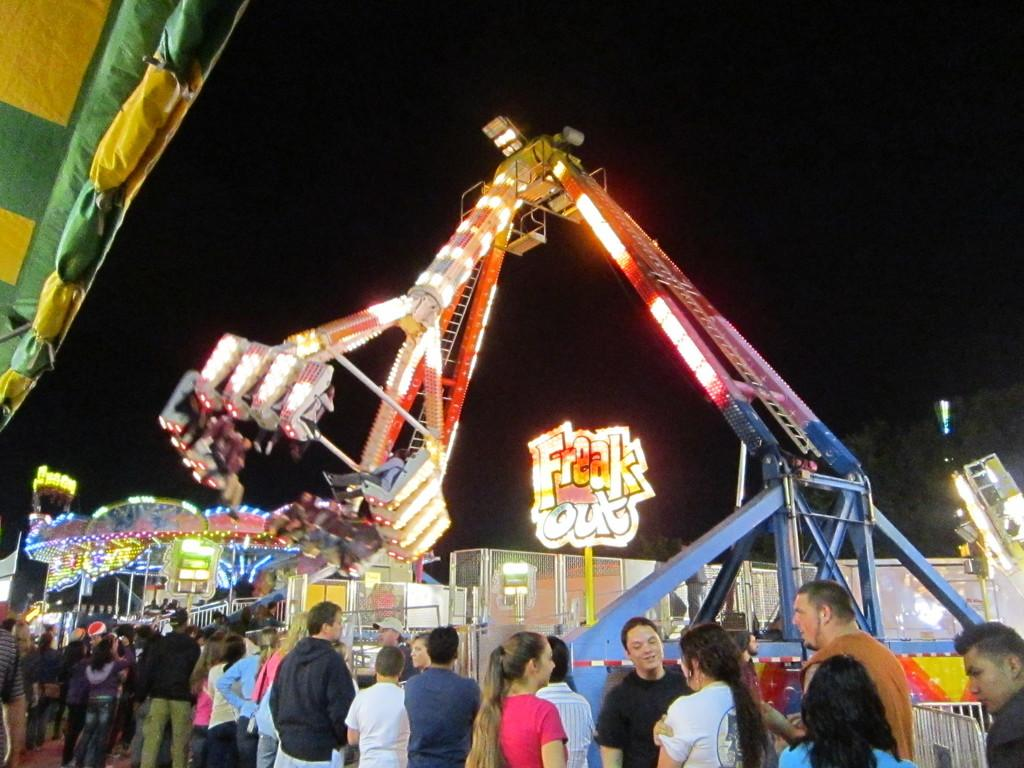What is the setting of the image? The image is taken at an exhibition. What are the people doing at the exhibition? People are enjoying rides in the exhibition. How many beggars can be seen in the image? There are no beggars present in the image; it features people enjoying rides at an exhibition. 